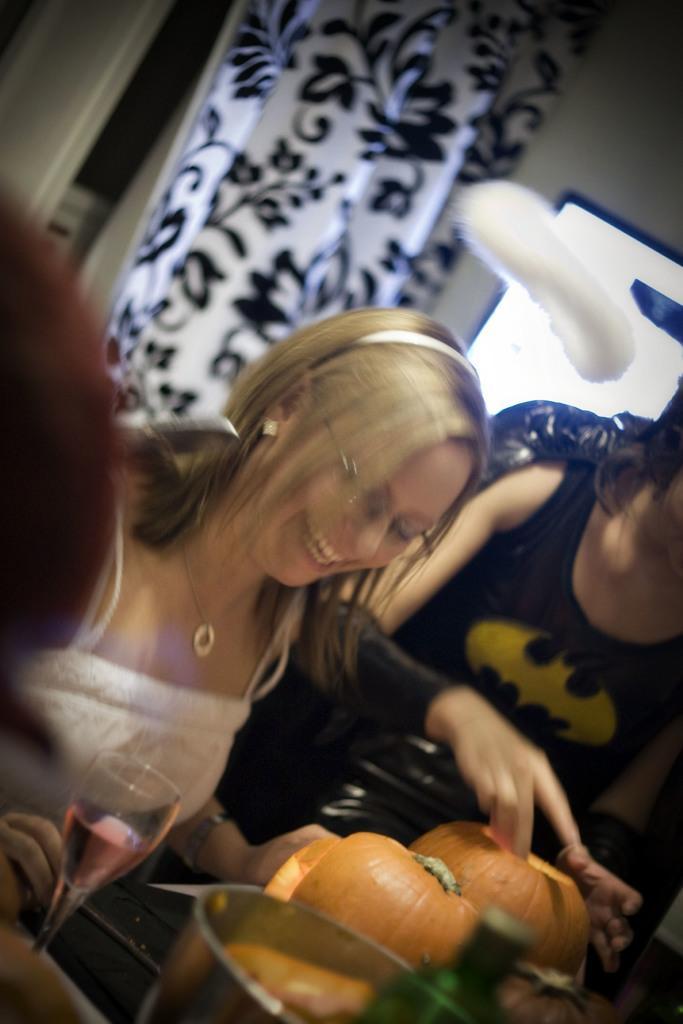Can you describe this image briefly? In this picture there is a woman who is wearing spectacle, locket and white dress. She is smiling. She is sitting near to the table. On the table we can see wine glass, bowls, pumpkins, water bottle and other objects. On the right there is a woman who is wearing batman t-shirt. In the background we can see door and window. 